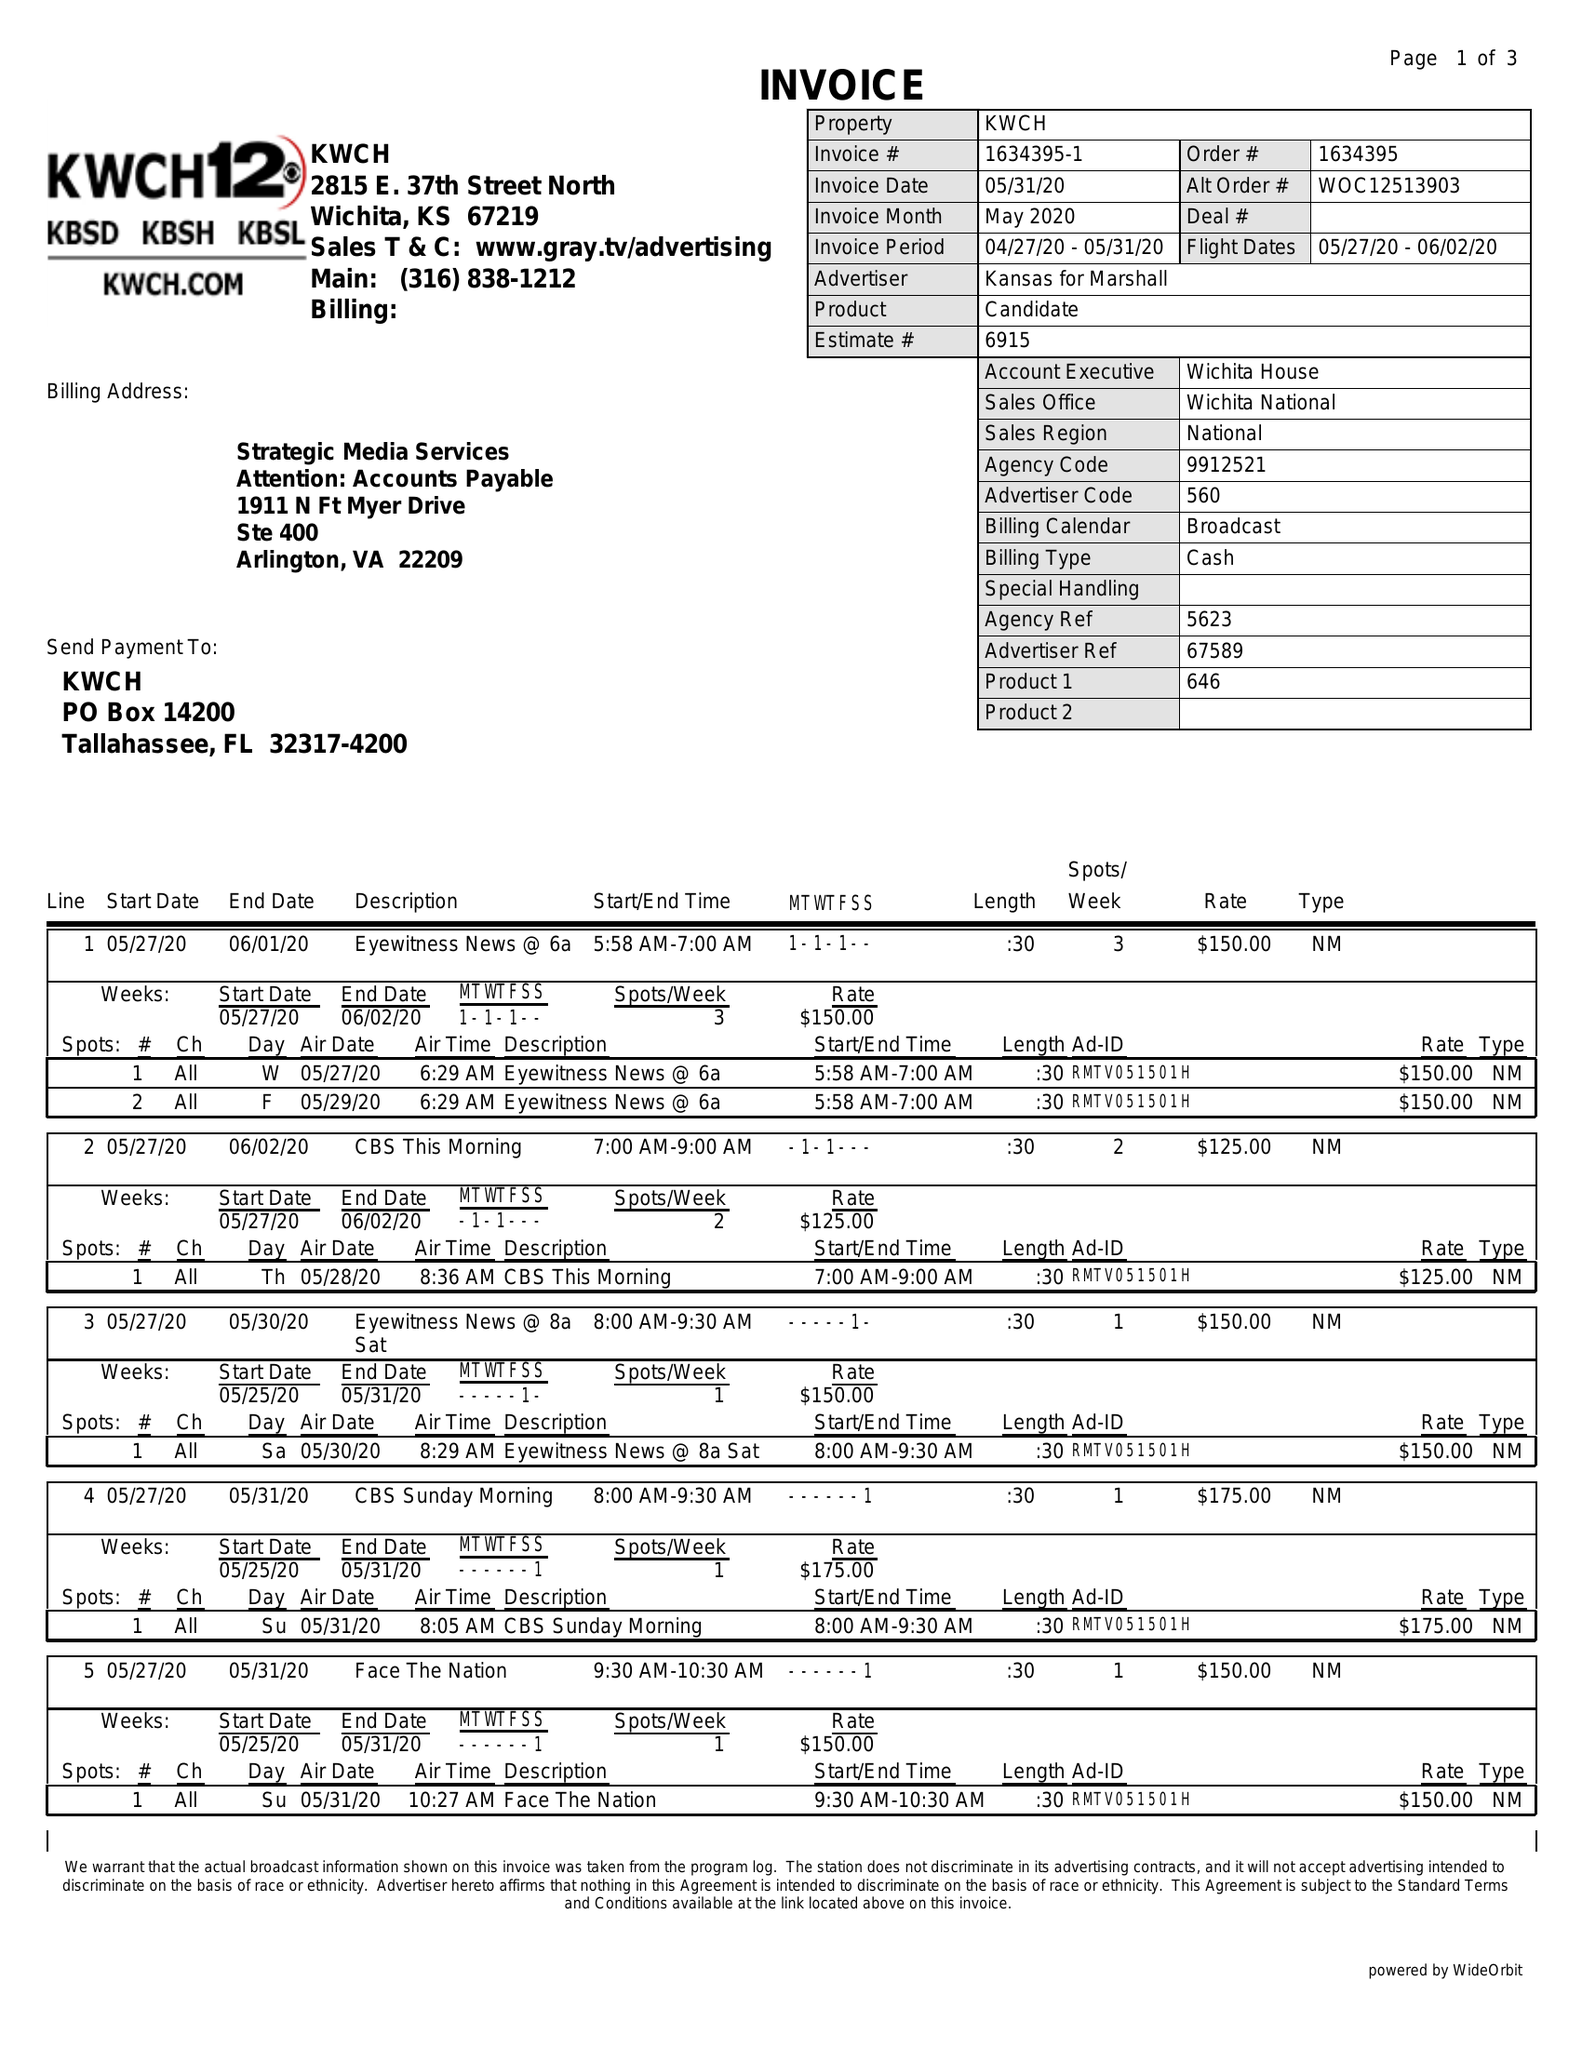What is the value for the gross_amount?
Answer the question using a single word or phrase. 4905.00 